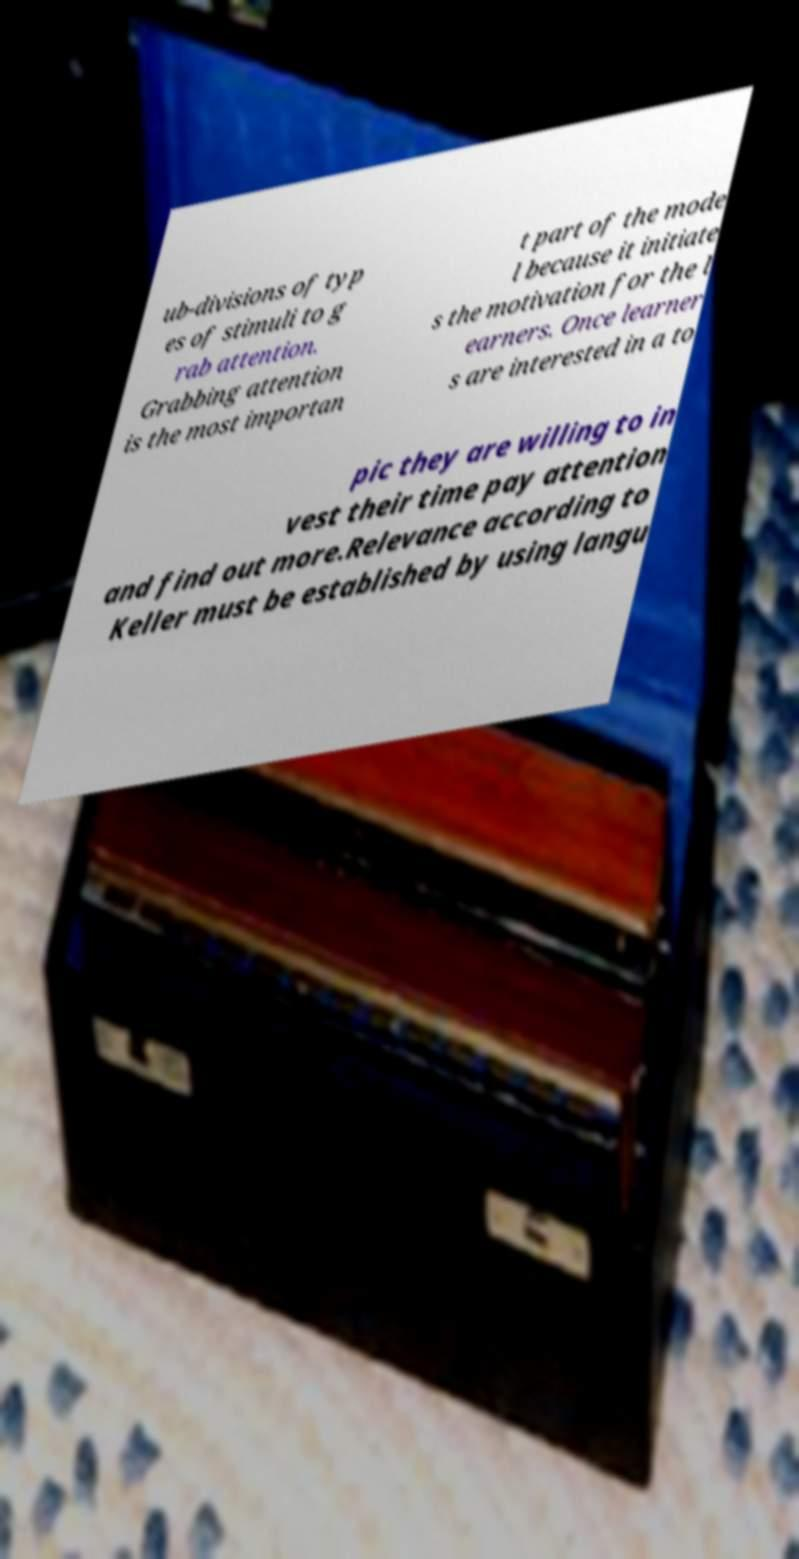There's text embedded in this image that I need extracted. Can you transcribe it verbatim? ub-divisions of typ es of stimuli to g rab attention. Grabbing attention is the most importan t part of the mode l because it initiate s the motivation for the l earners. Once learner s are interested in a to pic they are willing to in vest their time pay attention and find out more.Relevance according to Keller must be established by using langu 